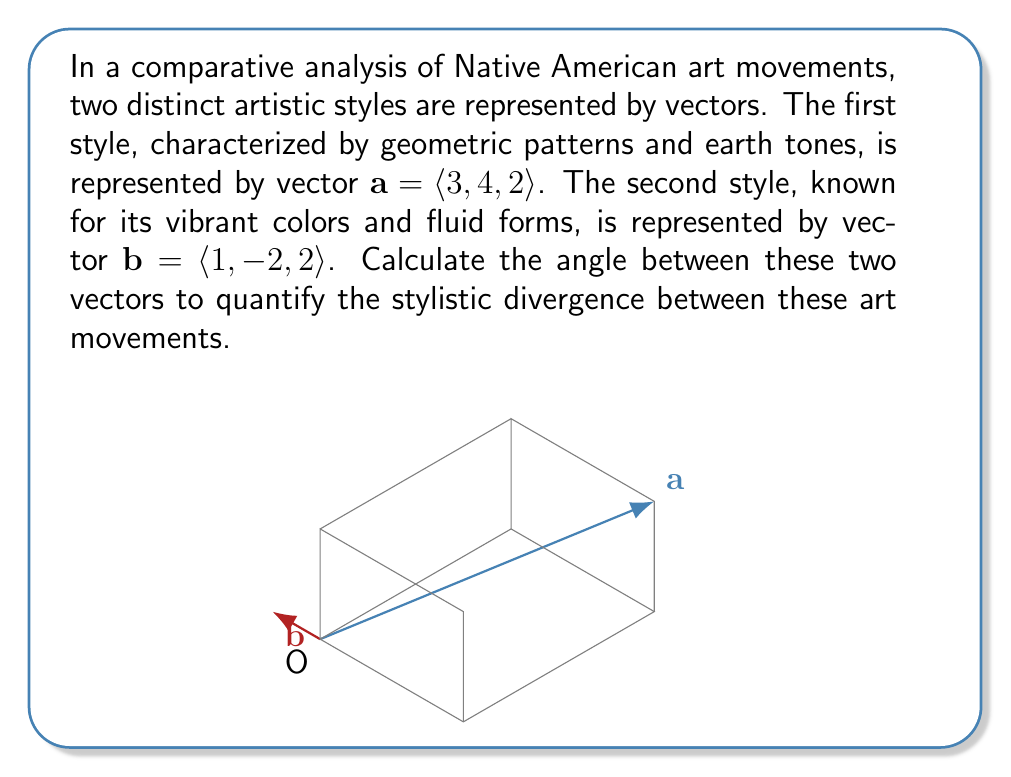Help me with this question. To find the angle between two vectors, we can use the dot product formula:

$$\cos \theta = \frac{\mathbf{a} \cdot \mathbf{b}}{|\mathbf{a}||\mathbf{b}|}$$

Step 1: Calculate the dot product $\mathbf{a} \cdot \mathbf{b}$
$$\mathbf{a} \cdot \mathbf{b} = (3)(1) + (4)(-2) + (2)(2) = 3 - 8 + 4 = -1$$

Step 2: Calculate the magnitudes of vectors $\mathbf{a}$ and $\mathbf{b}$
$$|\mathbf{a}| = \sqrt{3^2 + 4^2 + 2^2} = \sqrt{9 + 16 + 4} = \sqrt{29}$$
$$|\mathbf{b}| = \sqrt{1^2 + (-2)^2 + 2^2} = \sqrt{1 + 4 + 4} = 3$$

Step 3: Substitute into the formula
$$\cos \theta = \frac{-1}{\sqrt{29} \cdot 3} = \frac{-1}{3\sqrt{29}}$$

Step 4: Take the inverse cosine (arccos) of both sides
$$\theta = \arccos\left(\frac{-1}{3\sqrt{29}}\right)$$

Step 5: Calculate the result (rounded to two decimal places)
$$\theta \approx 1.76 \text{ radians} \approx 100.89\text{°}$$
Answer: $100.89\text{°}$ 